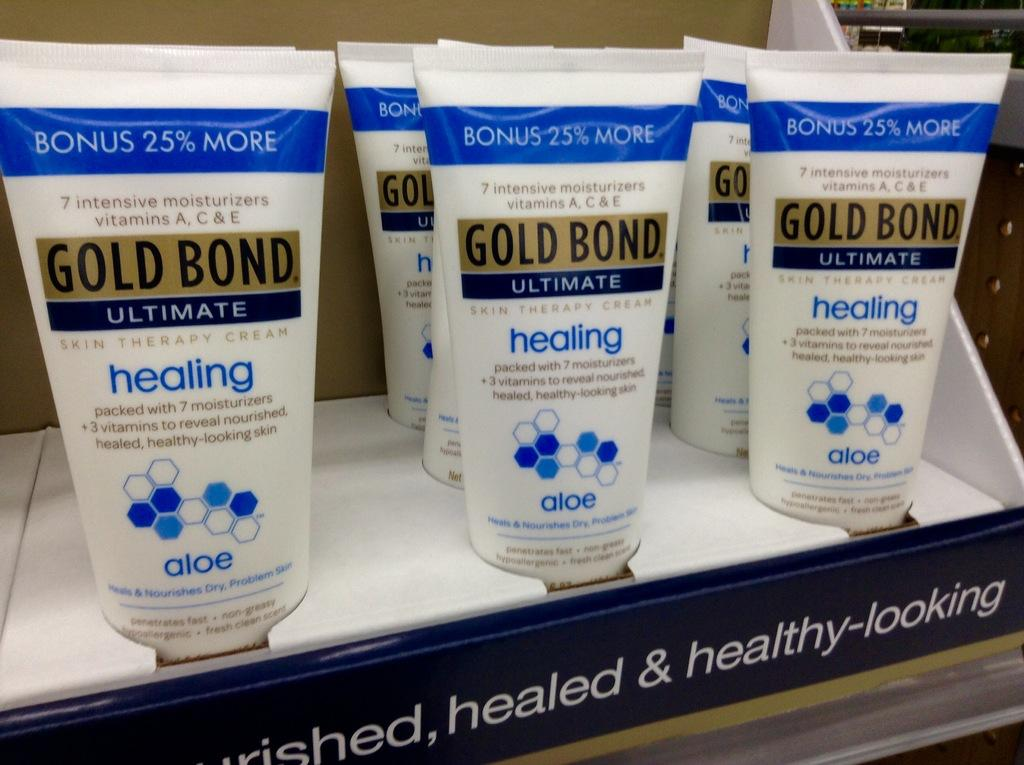<image>
Offer a succinct explanation of the picture presented. A store display of Gold Bond Ultimate healing skin therapy cream 